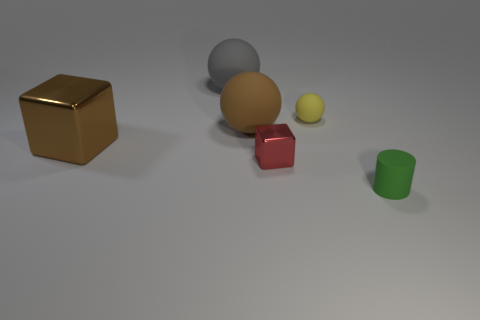What number of things are small yellow objects or rubber objects that are to the right of the large gray matte thing? 3 